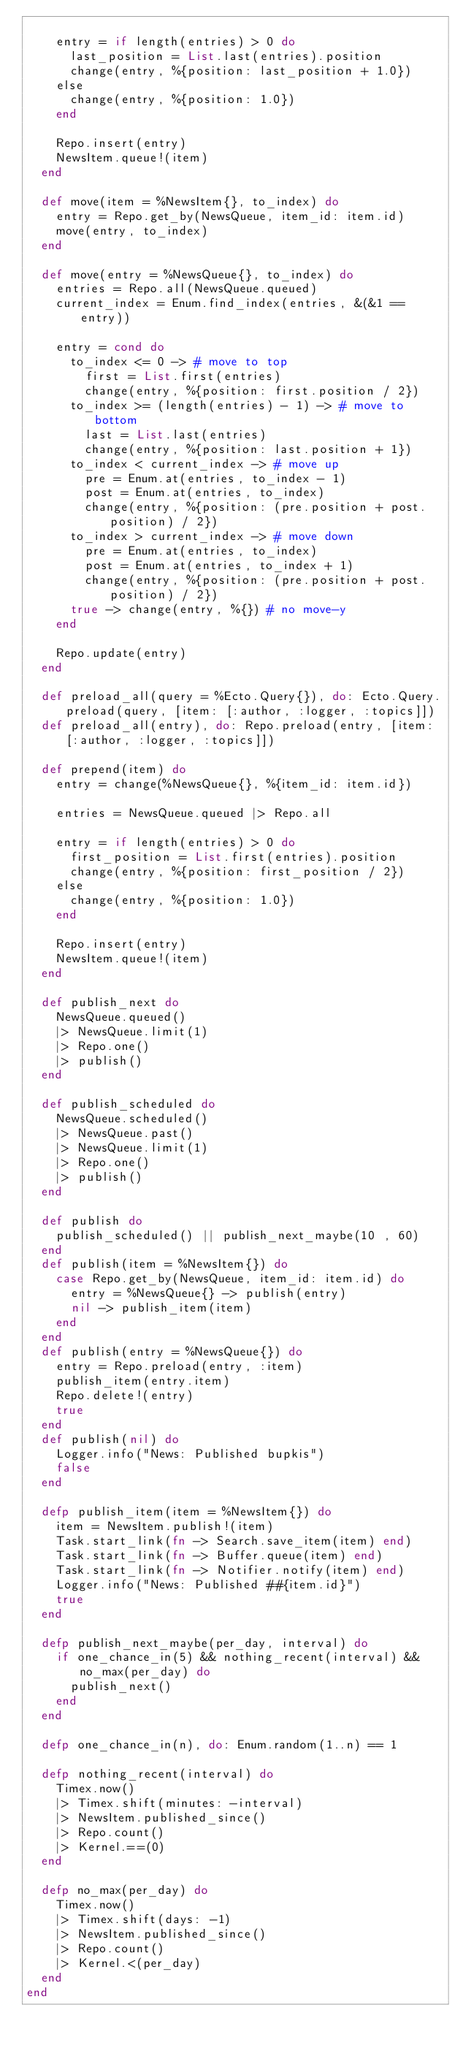Convert code to text. <code><loc_0><loc_0><loc_500><loc_500><_Elixir_>
    entry = if length(entries) > 0 do
      last_position = List.last(entries).position
      change(entry, %{position: last_position + 1.0})
    else
      change(entry, %{position: 1.0})
    end

    Repo.insert(entry)
    NewsItem.queue!(item)
  end

  def move(item = %NewsItem{}, to_index) do
    entry = Repo.get_by(NewsQueue, item_id: item.id)
    move(entry, to_index)
  end

  def move(entry = %NewsQueue{}, to_index) do
    entries = Repo.all(NewsQueue.queued)
    current_index = Enum.find_index(entries, &(&1 == entry))

    entry = cond do
      to_index <= 0 -> # move to top
        first = List.first(entries)
        change(entry, %{position: first.position / 2})
      to_index >= (length(entries) - 1) -> # move to bottom
        last = List.last(entries)
        change(entry, %{position: last.position + 1})
      to_index < current_index -> # move up
        pre = Enum.at(entries, to_index - 1)
        post = Enum.at(entries, to_index)
        change(entry, %{position: (pre.position + post.position) / 2})
      to_index > current_index -> # move down
        pre = Enum.at(entries, to_index)
        post = Enum.at(entries, to_index + 1)
        change(entry, %{position: (pre.position + post.position) / 2})
      true -> change(entry, %{}) # no move-y
    end

    Repo.update(entry)
  end

  def preload_all(query = %Ecto.Query{}), do: Ecto.Query.preload(query, [item: [:author, :logger, :topics]])
  def preload_all(entry), do: Repo.preload(entry, [item: [:author, :logger, :topics]])

  def prepend(item) do
    entry = change(%NewsQueue{}, %{item_id: item.id})

    entries = NewsQueue.queued |> Repo.all

    entry = if length(entries) > 0 do
      first_position = List.first(entries).position
      change(entry, %{position: first_position / 2})
    else
      change(entry, %{position: 1.0})
    end

    Repo.insert(entry)
    NewsItem.queue!(item)
  end

  def publish_next do
    NewsQueue.queued()
    |> NewsQueue.limit(1)
    |> Repo.one()
    |> publish()
  end

  def publish_scheduled do
    NewsQueue.scheduled()
    |> NewsQueue.past()
    |> NewsQueue.limit(1)
    |> Repo.one()
    |> publish()
  end

  def publish do
    publish_scheduled() || publish_next_maybe(10 , 60)
  end
  def publish(item = %NewsItem{}) do
    case Repo.get_by(NewsQueue, item_id: item.id) do
      entry = %NewsQueue{} -> publish(entry)
      nil -> publish_item(item)
    end
  end
  def publish(entry = %NewsQueue{}) do
    entry = Repo.preload(entry, :item)
    publish_item(entry.item)
    Repo.delete!(entry)
    true
  end
  def publish(nil) do
    Logger.info("News: Published bupkis")
    false
  end

  defp publish_item(item = %NewsItem{}) do
    item = NewsItem.publish!(item)
    Task.start_link(fn -> Search.save_item(item) end)
    Task.start_link(fn -> Buffer.queue(item) end)
    Task.start_link(fn -> Notifier.notify(item) end)
    Logger.info("News: Published ##{item.id}")
    true
  end

  defp publish_next_maybe(per_day, interval) do
    if one_chance_in(5) && nothing_recent(interval) && no_max(per_day) do
      publish_next()
    end
  end

  defp one_chance_in(n), do: Enum.random(1..n) == 1

  defp nothing_recent(interval) do
    Timex.now()
    |> Timex.shift(minutes: -interval)
    |> NewsItem.published_since()
    |> Repo.count()
    |> Kernel.==(0)
  end

  defp no_max(per_day) do
    Timex.now()
    |> Timex.shift(days: -1)
    |> NewsItem.published_since()
    |> Repo.count()
    |> Kernel.<(per_day)
  end
end
</code> 